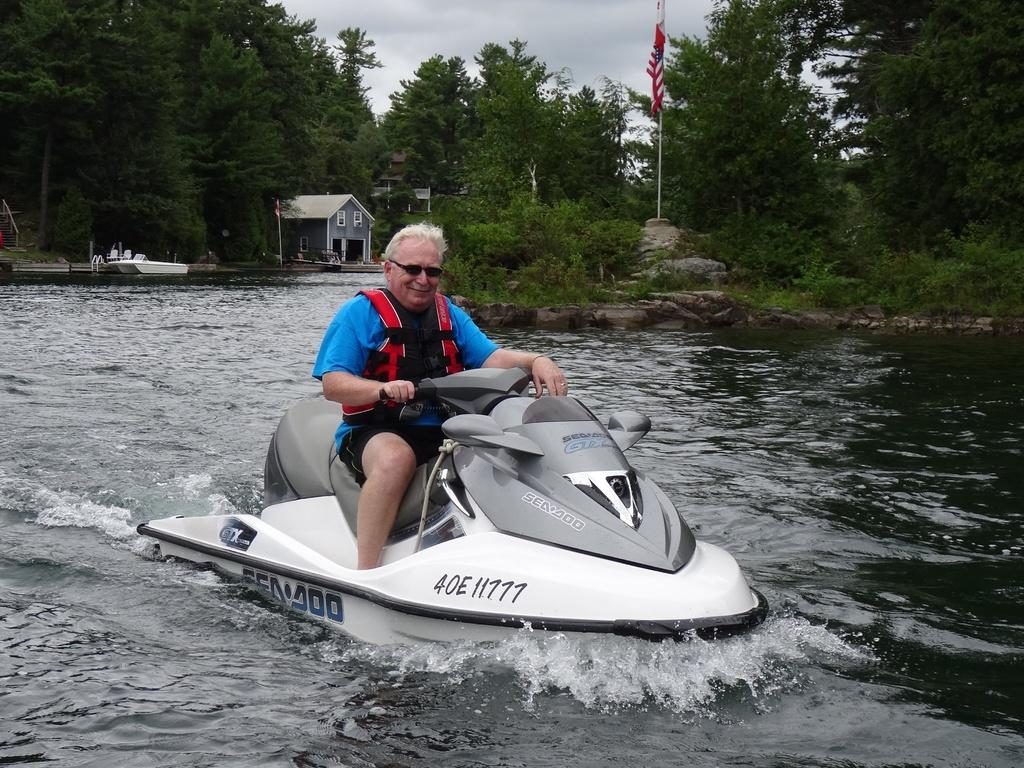Provide a one-sentence caption for the provided image. A man in a blue shirt is riding a white Sea Doo waverunner. 